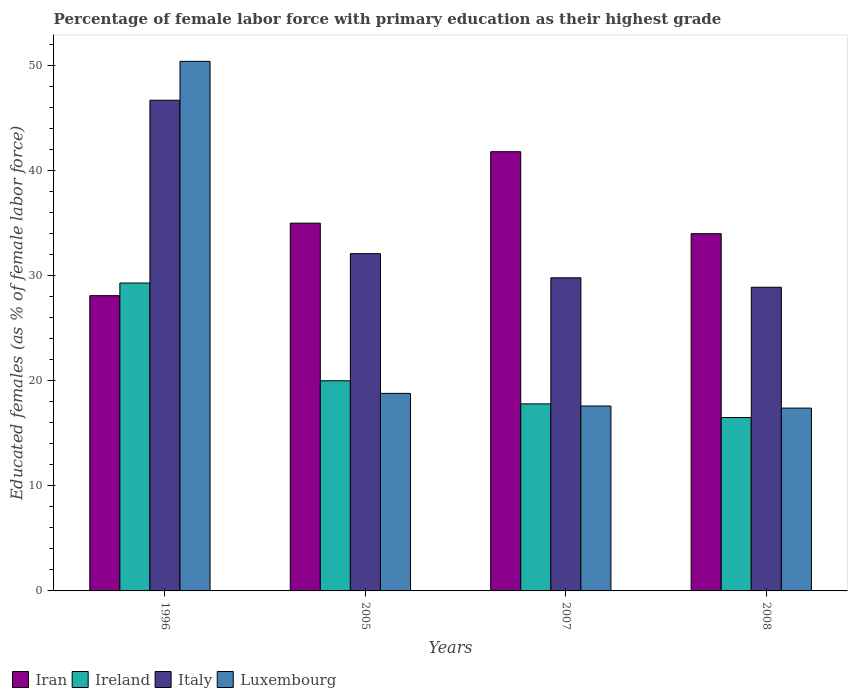How many different coloured bars are there?
Provide a short and direct response. 4. How many bars are there on the 3rd tick from the left?
Your response must be concise. 4. How many bars are there on the 4th tick from the right?
Make the answer very short. 4. What is the label of the 1st group of bars from the left?
Keep it short and to the point. 1996. In how many cases, is the number of bars for a given year not equal to the number of legend labels?
Offer a terse response. 0. What is the percentage of female labor force with primary education in Italy in 2007?
Your response must be concise. 29.8. Across all years, what is the maximum percentage of female labor force with primary education in Ireland?
Your response must be concise. 29.3. Across all years, what is the minimum percentage of female labor force with primary education in Iran?
Your answer should be very brief. 28.1. In which year was the percentage of female labor force with primary education in Ireland maximum?
Make the answer very short. 1996. What is the total percentage of female labor force with primary education in Italy in the graph?
Your answer should be compact. 137.5. What is the difference between the percentage of female labor force with primary education in Ireland in 1996 and that in 2007?
Provide a short and direct response. 11.5. What is the difference between the percentage of female labor force with primary education in Iran in 2008 and the percentage of female labor force with primary education in Italy in 2005?
Make the answer very short. 1.9. What is the average percentage of female labor force with primary education in Luxembourg per year?
Keep it short and to the point. 26.05. In the year 2008, what is the difference between the percentage of female labor force with primary education in Ireland and percentage of female labor force with primary education in Luxembourg?
Offer a terse response. -0.9. What is the ratio of the percentage of female labor force with primary education in Luxembourg in 2005 to that in 2007?
Provide a short and direct response. 1.07. Is the percentage of female labor force with primary education in Luxembourg in 1996 less than that in 2007?
Give a very brief answer. No. What is the difference between the highest and the second highest percentage of female labor force with primary education in Iran?
Provide a succinct answer. 6.8. What is the difference between the highest and the lowest percentage of female labor force with primary education in Ireland?
Your response must be concise. 12.8. Is it the case that in every year, the sum of the percentage of female labor force with primary education in Luxembourg and percentage of female labor force with primary education in Iran is greater than the sum of percentage of female labor force with primary education in Italy and percentage of female labor force with primary education in Ireland?
Your answer should be very brief. No. What does the 1st bar from the left in 2008 represents?
Your response must be concise. Iran. What does the 4th bar from the right in 2005 represents?
Provide a succinct answer. Iran. Is it the case that in every year, the sum of the percentage of female labor force with primary education in Iran and percentage of female labor force with primary education in Italy is greater than the percentage of female labor force with primary education in Luxembourg?
Your response must be concise. Yes. Are all the bars in the graph horizontal?
Provide a succinct answer. No. How many years are there in the graph?
Your answer should be very brief. 4. Are the values on the major ticks of Y-axis written in scientific E-notation?
Your answer should be very brief. No. How many legend labels are there?
Your response must be concise. 4. How are the legend labels stacked?
Give a very brief answer. Horizontal. What is the title of the graph?
Your response must be concise. Percentage of female labor force with primary education as their highest grade. Does "High income" appear as one of the legend labels in the graph?
Provide a short and direct response. No. What is the label or title of the X-axis?
Your response must be concise. Years. What is the label or title of the Y-axis?
Make the answer very short. Educated females (as % of female labor force). What is the Educated females (as % of female labor force) of Iran in 1996?
Keep it short and to the point. 28.1. What is the Educated females (as % of female labor force) in Ireland in 1996?
Provide a succinct answer. 29.3. What is the Educated females (as % of female labor force) of Italy in 1996?
Provide a succinct answer. 46.7. What is the Educated females (as % of female labor force) of Luxembourg in 1996?
Your answer should be very brief. 50.4. What is the Educated females (as % of female labor force) of Iran in 2005?
Your response must be concise. 35. What is the Educated females (as % of female labor force) of Ireland in 2005?
Keep it short and to the point. 20. What is the Educated females (as % of female labor force) in Italy in 2005?
Offer a very short reply. 32.1. What is the Educated females (as % of female labor force) in Luxembourg in 2005?
Give a very brief answer. 18.8. What is the Educated females (as % of female labor force) in Iran in 2007?
Make the answer very short. 41.8. What is the Educated females (as % of female labor force) in Ireland in 2007?
Keep it short and to the point. 17.8. What is the Educated females (as % of female labor force) in Italy in 2007?
Keep it short and to the point. 29.8. What is the Educated females (as % of female labor force) in Luxembourg in 2007?
Offer a terse response. 17.6. What is the Educated females (as % of female labor force) of Italy in 2008?
Offer a very short reply. 28.9. What is the Educated females (as % of female labor force) of Luxembourg in 2008?
Make the answer very short. 17.4. Across all years, what is the maximum Educated females (as % of female labor force) of Iran?
Your answer should be very brief. 41.8. Across all years, what is the maximum Educated females (as % of female labor force) of Ireland?
Offer a terse response. 29.3. Across all years, what is the maximum Educated females (as % of female labor force) in Italy?
Offer a terse response. 46.7. Across all years, what is the maximum Educated females (as % of female labor force) in Luxembourg?
Offer a terse response. 50.4. Across all years, what is the minimum Educated females (as % of female labor force) of Iran?
Ensure brevity in your answer.  28.1. Across all years, what is the minimum Educated females (as % of female labor force) in Ireland?
Provide a short and direct response. 16.5. Across all years, what is the minimum Educated females (as % of female labor force) in Italy?
Your answer should be very brief. 28.9. Across all years, what is the minimum Educated females (as % of female labor force) in Luxembourg?
Your answer should be compact. 17.4. What is the total Educated females (as % of female labor force) of Iran in the graph?
Your answer should be compact. 138.9. What is the total Educated females (as % of female labor force) of Ireland in the graph?
Ensure brevity in your answer.  83.6. What is the total Educated females (as % of female labor force) of Italy in the graph?
Your answer should be compact. 137.5. What is the total Educated females (as % of female labor force) in Luxembourg in the graph?
Keep it short and to the point. 104.2. What is the difference between the Educated females (as % of female labor force) in Ireland in 1996 and that in 2005?
Ensure brevity in your answer.  9.3. What is the difference between the Educated females (as % of female labor force) of Luxembourg in 1996 and that in 2005?
Make the answer very short. 31.6. What is the difference between the Educated females (as % of female labor force) in Iran in 1996 and that in 2007?
Your response must be concise. -13.7. What is the difference between the Educated females (as % of female labor force) of Luxembourg in 1996 and that in 2007?
Your response must be concise. 32.8. What is the difference between the Educated females (as % of female labor force) of Iran in 1996 and that in 2008?
Provide a succinct answer. -5.9. What is the difference between the Educated females (as % of female labor force) in Ireland in 1996 and that in 2008?
Provide a short and direct response. 12.8. What is the difference between the Educated females (as % of female labor force) in Luxembourg in 1996 and that in 2008?
Ensure brevity in your answer.  33. What is the difference between the Educated females (as % of female labor force) of Ireland in 2005 and that in 2007?
Give a very brief answer. 2.2. What is the difference between the Educated females (as % of female labor force) of Luxembourg in 2005 and that in 2007?
Provide a succinct answer. 1.2. What is the difference between the Educated females (as % of female labor force) in Iran in 2005 and that in 2008?
Provide a short and direct response. 1. What is the difference between the Educated females (as % of female labor force) of Italy in 2007 and that in 2008?
Give a very brief answer. 0.9. What is the difference between the Educated females (as % of female labor force) of Ireland in 1996 and the Educated females (as % of female labor force) of Italy in 2005?
Your answer should be very brief. -2.8. What is the difference between the Educated females (as % of female labor force) in Italy in 1996 and the Educated females (as % of female labor force) in Luxembourg in 2005?
Offer a very short reply. 27.9. What is the difference between the Educated females (as % of female labor force) in Iran in 1996 and the Educated females (as % of female labor force) in Ireland in 2007?
Keep it short and to the point. 10.3. What is the difference between the Educated females (as % of female labor force) of Ireland in 1996 and the Educated females (as % of female labor force) of Luxembourg in 2007?
Your answer should be very brief. 11.7. What is the difference between the Educated females (as % of female labor force) of Italy in 1996 and the Educated females (as % of female labor force) of Luxembourg in 2007?
Ensure brevity in your answer.  29.1. What is the difference between the Educated females (as % of female labor force) of Iran in 1996 and the Educated females (as % of female labor force) of Ireland in 2008?
Make the answer very short. 11.6. What is the difference between the Educated females (as % of female labor force) of Iran in 1996 and the Educated females (as % of female labor force) of Luxembourg in 2008?
Your answer should be compact. 10.7. What is the difference between the Educated females (as % of female labor force) of Ireland in 1996 and the Educated females (as % of female labor force) of Luxembourg in 2008?
Ensure brevity in your answer.  11.9. What is the difference between the Educated females (as % of female labor force) in Italy in 1996 and the Educated females (as % of female labor force) in Luxembourg in 2008?
Give a very brief answer. 29.3. What is the difference between the Educated females (as % of female labor force) in Iran in 2005 and the Educated females (as % of female labor force) in Luxembourg in 2007?
Make the answer very short. 17.4. What is the difference between the Educated females (as % of female labor force) in Iran in 2005 and the Educated females (as % of female labor force) in Ireland in 2008?
Provide a short and direct response. 18.5. What is the difference between the Educated females (as % of female labor force) of Iran in 2005 and the Educated females (as % of female labor force) of Italy in 2008?
Give a very brief answer. 6.1. What is the difference between the Educated females (as % of female labor force) of Iran in 2005 and the Educated females (as % of female labor force) of Luxembourg in 2008?
Keep it short and to the point. 17.6. What is the difference between the Educated females (as % of female labor force) in Ireland in 2005 and the Educated females (as % of female labor force) in Luxembourg in 2008?
Provide a succinct answer. 2.6. What is the difference between the Educated females (as % of female labor force) in Iran in 2007 and the Educated females (as % of female labor force) in Ireland in 2008?
Ensure brevity in your answer.  25.3. What is the difference between the Educated females (as % of female labor force) of Iran in 2007 and the Educated females (as % of female labor force) of Luxembourg in 2008?
Provide a succinct answer. 24.4. What is the difference between the Educated females (as % of female labor force) in Ireland in 2007 and the Educated females (as % of female labor force) in Luxembourg in 2008?
Give a very brief answer. 0.4. What is the difference between the Educated females (as % of female labor force) in Italy in 2007 and the Educated females (as % of female labor force) in Luxembourg in 2008?
Ensure brevity in your answer.  12.4. What is the average Educated females (as % of female labor force) of Iran per year?
Your answer should be compact. 34.73. What is the average Educated females (as % of female labor force) in Ireland per year?
Keep it short and to the point. 20.9. What is the average Educated females (as % of female labor force) of Italy per year?
Make the answer very short. 34.38. What is the average Educated females (as % of female labor force) of Luxembourg per year?
Offer a terse response. 26.05. In the year 1996, what is the difference between the Educated females (as % of female labor force) of Iran and Educated females (as % of female labor force) of Ireland?
Keep it short and to the point. -1.2. In the year 1996, what is the difference between the Educated females (as % of female labor force) of Iran and Educated females (as % of female labor force) of Italy?
Your answer should be very brief. -18.6. In the year 1996, what is the difference between the Educated females (as % of female labor force) in Iran and Educated females (as % of female labor force) in Luxembourg?
Offer a terse response. -22.3. In the year 1996, what is the difference between the Educated females (as % of female labor force) in Ireland and Educated females (as % of female labor force) in Italy?
Provide a short and direct response. -17.4. In the year 1996, what is the difference between the Educated females (as % of female labor force) in Ireland and Educated females (as % of female labor force) in Luxembourg?
Your answer should be very brief. -21.1. In the year 2005, what is the difference between the Educated females (as % of female labor force) of Iran and Educated females (as % of female labor force) of Luxembourg?
Keep it short and to the point. 16.2. In the year 2005, what is the difference between the Educated females (as % of female labor force) of Italy and Educated females (as % of female labor force) of Luxembourg?
Your answer should be very brief. 13.3. In the year 2007, what is the difference between the Educated females (as % of female labor force) of Iran and Educated females (as % of female labor force) of Luxembourg?
Ensure brevity in your answer.  24.2. In the year 2008, what is the difference between the Educated females (as % of female labor force) of Iran and Educated females (as % of female labor force) of Luxembourg?
Your answer should be very brief. 16.6. In the year 2008, what is the difference between the Educated females (as % of female labor force) of Ireland and Educated females (as % of female labor force) of Luxembourg?
Your response must be concise. -0.9. What is the ratio of the Educated females (as % of female labor force) of Iran in 1996 to that in 2005?
Keep it short and to the point. 0.8. What is the ratio of the Educated females (as % of female labor force) of Ireland in 1996 to that in 2005?
Provide a short and direct response. 1.47. What is the ratio of the Educated females (as % of female labor force) in Italy in 1996 to that in 2005?
Give a very brief answer. 1.45. What is the ratio of the Educated females (as % of female labor force) in Luxembourg in 1996 to that in 2005?
Give a very brief answer. 2.68. What is the ratio of the Educated females (as % of female labor force) in Iran in 1996 to that in 2007?
Ensure brevity in your answer.  0.67. What is the ratio of the Educated females (as % of female labor force) of Ireland in 1996 to that in 2007?
Your answer should be compact. 1.65. What is the ratio of the Educated females (as % of female labor force) of Italy in 1996 to that in 2007?
Offer a terse response. 1.57. What is the ratio of the Educated females (as % of female labor force) of Luxembourg in 1996 to that in 2007?
Provide a succinct answer. 2.86. What is the ratio of the Educated females (as % of female labor force) of Iran in 1996 to that in 2008?
Keep it short and to the point. 0.83. What is the ratio of the Educated females (as % of female labor force) of Ireland in 1996 to that in 2008?
Make the answer very short. 1.78. What is the ratio of the Educated females (as % of female labor force) of Italy in 1996 to that in 2008?
Your response must be concise. 1.62. What is the ratio of the Educated females (as % of female labor force) of Luxembourg in 1996 to that in 2008?
Make the answer very short. 2.9. What is the ratio of the Educated females (as % of female labor force) in Iran in 2005 to that in 2007?
Make the answer very short. 0.84. What is the ratio of the Educated females (as % of female labor force) of Ireland in 2005 to that in 2007?
Give a very brief answer. 1.12. What is the ratio of the Educated females (as % of female labor force) in Italy in 2005 to that in 2007?
Make the answer very short. 1.08. What is the ratio of the Educated females (as % of female labor force) in Luxembourg in 2005 to that in 2007?
Give a very brief answer. 1.07. What is the ratio of the Educated females (as % of female labor force) of Iran in 2005 to that in 2008?
Give a very brief answer. 1.03. What is the ratio of the Educated females (as % of female labor force) of Ireland in 2005 to that in 2008?
Your answer should be very brief. 1.21. What is the ratio of the Educated females (as % of female labor force) in Italy in 2005 to that in 2008?
Keep it short and to the point. 1.11. What is the ratio of the Educated females (as % of female labor force) of Luxembourg in 2005 to that in 2008?
Ensure brevity in your answer.  1.08. What is the ratio of the Educated females (as % of female labor force) of Iran in 2007 to that in 2008?
Your answer should be very brief. 1.23. What is the ratio of the Educated females (as % of female labor force) of Ireland in 2007 to that in 2008?
Your answer should be compact. 1.08. What is the ratio of the Educated females (as % of female labor force) in Italy in 2007 to that in 2008?
Offer a very short reply. 1.03. What is the ratio of the Educated females (as % of female labor force) of Luxembourg in 2007 to that in 2008?
Provide a short and direct response. 1.01. What is the difference between the highest and the second highest Educated females (as % of female labor force) in Luxembourg?
Your answer should be compact. 31.6. 